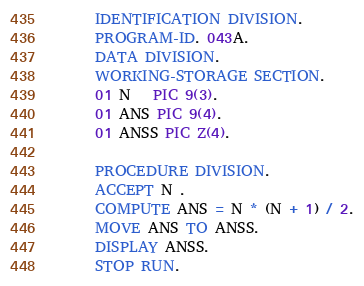Convert code to text. <code><loc_0><loc_0><loc_500><loc_500><_COBOL_>      IDENTIFICATION DIVISION.
      PROGRAM-ID. 043A.
      DATA DIVISION.
      WORKING-STORAGE SECTION.
      01 N   PIC 9(3).
      01 ANS PIC 9(4).
      01 ANSS PIC Z(4).
      
      PROCEDURE DIVISION.
      ACCEPT N .
      COMPUTE ANS = N * (N + 1) / 2.
      MOVE ANS TO ANSS.
      DISPLAY ANSS.
      STOP RUN.</code> 